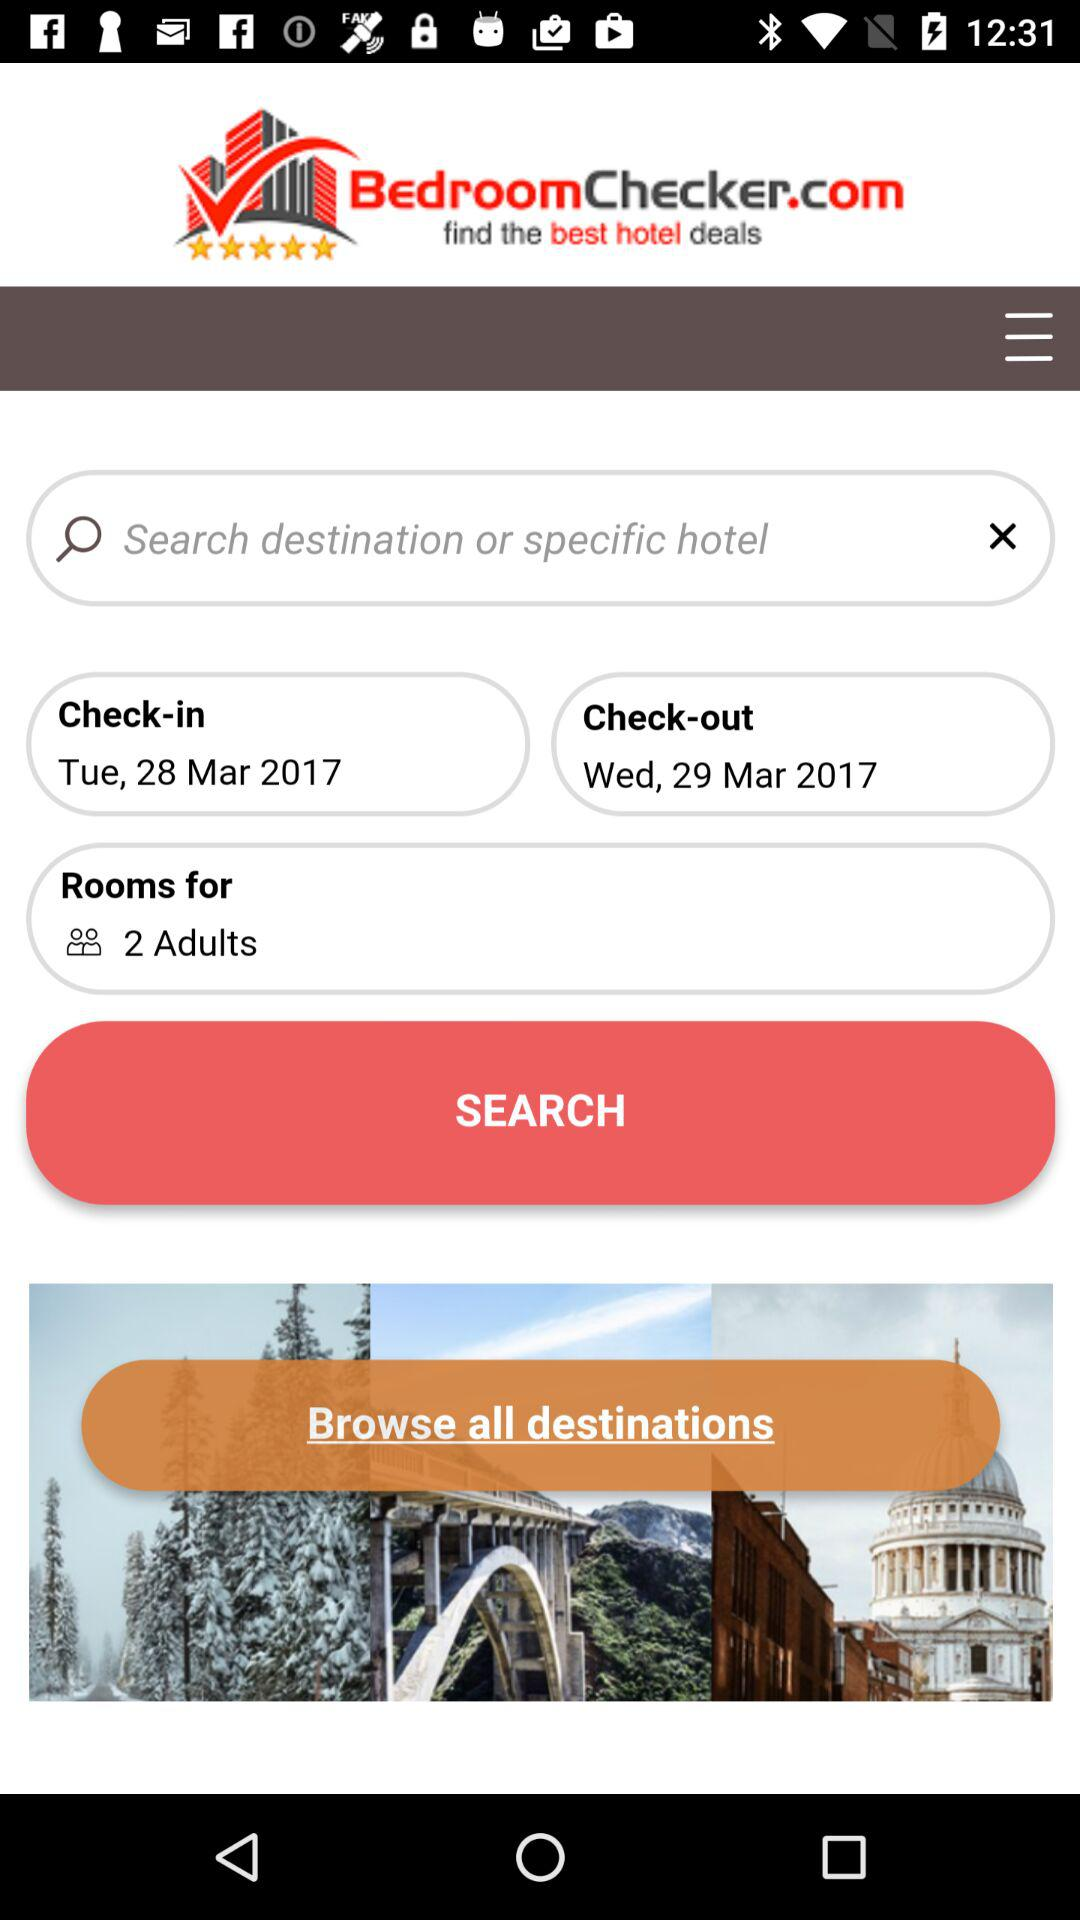What is the check-out date? The check-out date is Wednesday, March 29, 2017. 